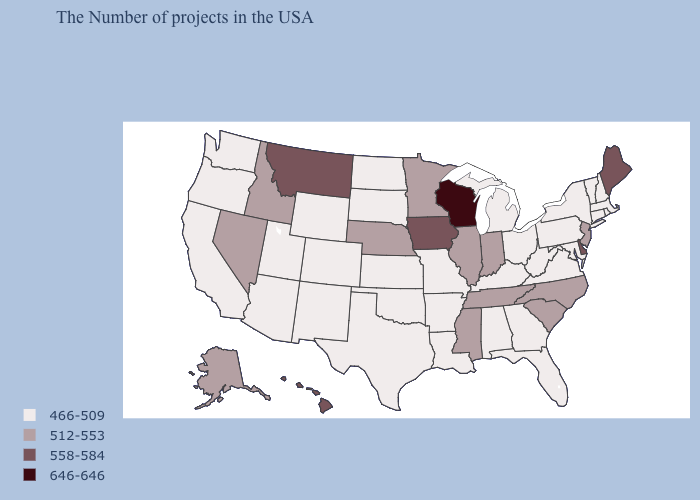Which states have the lowest value in the West?
Quick response, please. Wyoming, Colorado, New Mexico, Utah, Arizona, California, Washington, Oregon. Among the states that border Michigan , does Ohio have the lowest value?
Short answer required. Yes. Does Wisconsin have the highest value in the USA?
Give a very brief answer. Yes. What is the value of Florida?
Concise answer only. 466-509. What is the lowest value in the USA?
Answer briefly. 466-509. Does Massachusetts have a higher value than Vermont?
Write a very short answer. No. Among the states that border Wisconsin , does Michigan have the highest value?
Write a very short answer. No. Among the states that border Connecticut , which have the highest value?
Be succinct. Massachusetts, Rhode Island, New York. Does Wisconsin have the highest value in the USA?
Write a very short answer. Yes. What is the value of Iowa?
Keep it brief. 558-584. Is the legend a continuous bar?
Concise answer only. No. Name the states that have a value in the range 512-553?
Concise answer only. New Jersey, North Carolina, South Carolina, Indiana, Tennessee, Illinois, Mississippi, Minnesota, Nebraska, Idaho, Nevada, Alaska. Name the states that have a value in the range 646-646?
Short answer required. Wisconsin. What is the highest value in the USA?
Concise answer only. 646-646. What is the lowest value in states that border North Dakota?
Answer briefly. 466-509. 